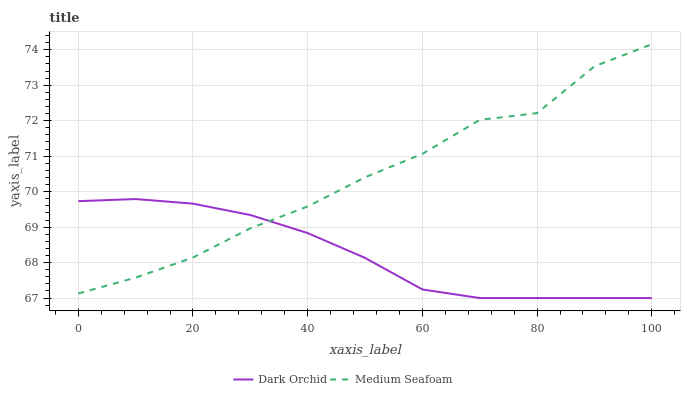Does Dark Orchid have the maximum area under the curve?
Answer yes or no. No. Is Dark Orchid the roughest?
Answer yes or no. No. Does Dark Orchid have the highest value?
Answer yes or no. No. 